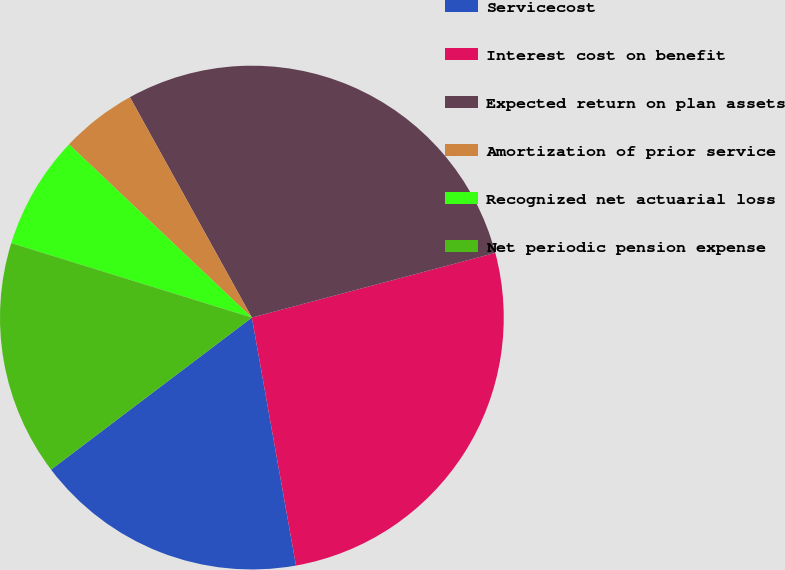Convert chart to OTSL. <chart><loc_0><loc_0><loc_500><loc_500><pie_chart><fcel>Servicecost<fcel>Interest cost on benefit<fcel>Expected return on plan assets<fcel>Amortization of prior service<fcel>Recognized net actuarial loss<fcel>Net periodic pension expense<nl><fcel>17.49%<fcel>26.33%<fcel>28.91%<fcel>4.89%<fcel>7.29%<fcel>15.09%<nl></chart> 